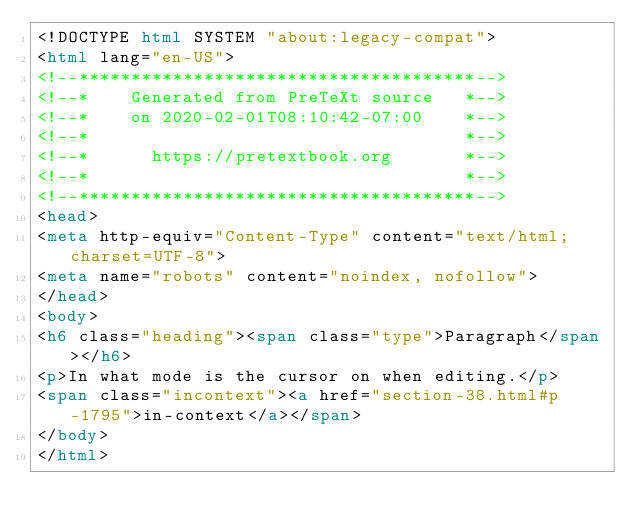Convert code to text. <code><loc_0><loc_0><loc_500><loc_500><_HTML_><!DOCTYPE html SYSTEM "about:legacy-compat">
<html lang="en-US">
<!--**************************************-->
<!--*    Generated from PreTeXt source   *-->
<!--*    on 2020-02-01T08:10:42-07:00    *-->
<!--*                                    *-->
<!--*      https://pretextbook.org       *-->
<!--*                                    *-->
<!--**************************************-->
<head>
<meta http-equiv="Content-Type" content="text/html; charset=UTF-8">
<meta name="robots" content="noindex, nofollow">
</head>
<body>
<h6 class="heading"><span class="type">Paragraph</span></h6>
<p>In what mode is the cursor on when editing.</p>
<span class="incontext"><a href="section-38.html#p-1795">in-context</a></span>
</body>
</html>
</code> 